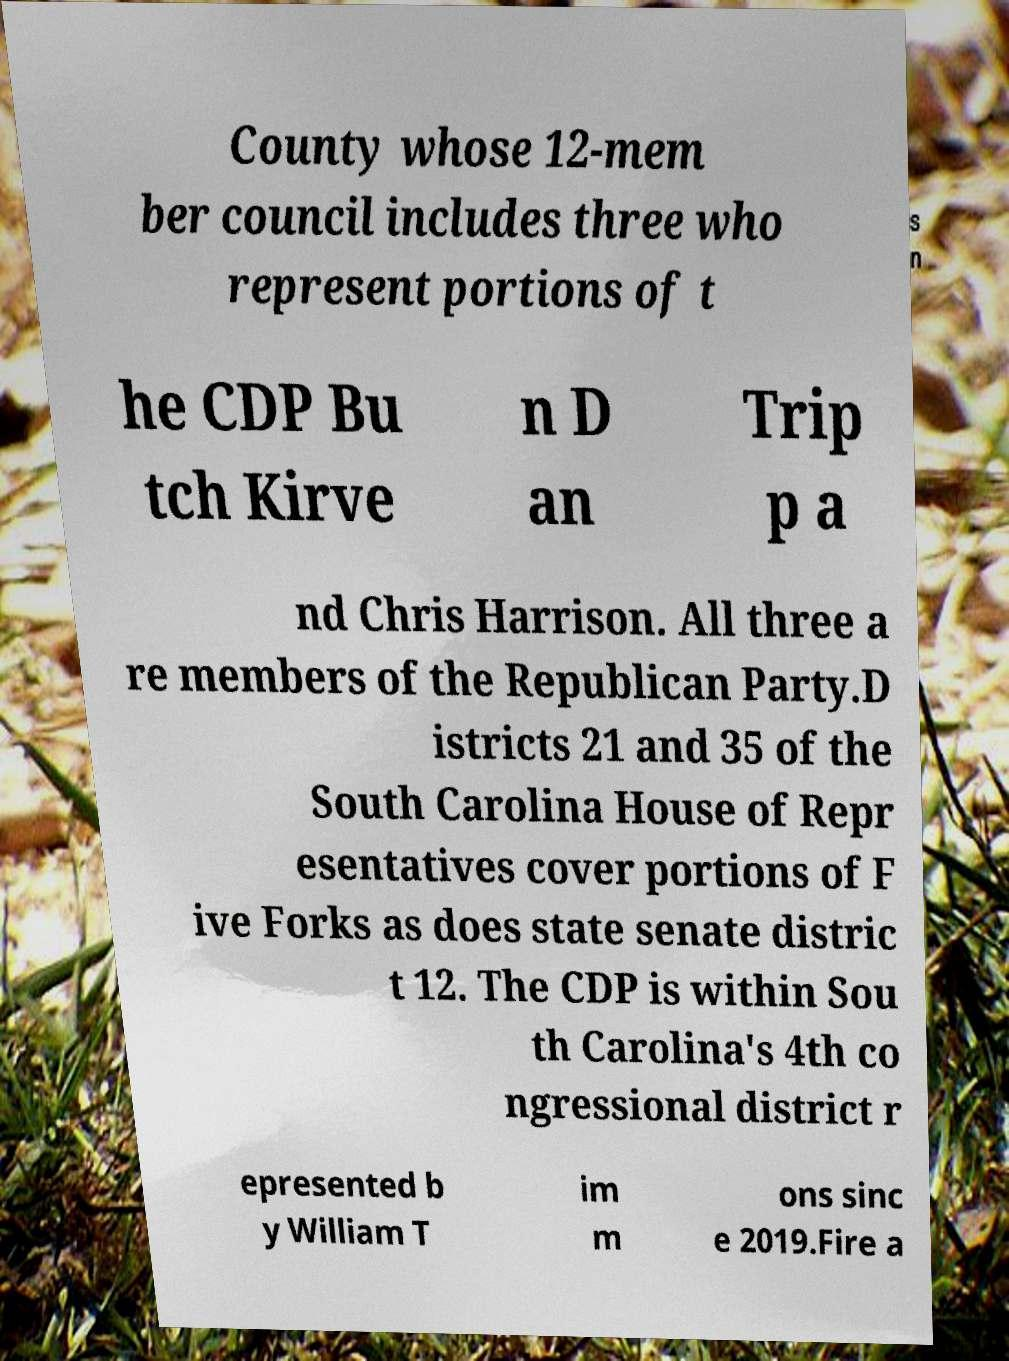Please identify and transcribe the text found in this image. County whose 12-mem ber council includes three who represent portions of t he CDP Bu tch Kirve n D an Trip p a nd Chris Harrison. All three a re members of the Republican Party.D istricts 21 and 35 of the South Carolina House of Repr esentatives cover portions of F ive Forks as does state senate distric t 12. The CDP is within Sou th Carolina's 4th co ngressional district r epresented b y William T im m ons sinc e 2019.Fire a 